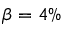Convert formula to latex. <formula><loc_0><loc_0><loc_500><loc_500>\beta = 4 \%</formula> 